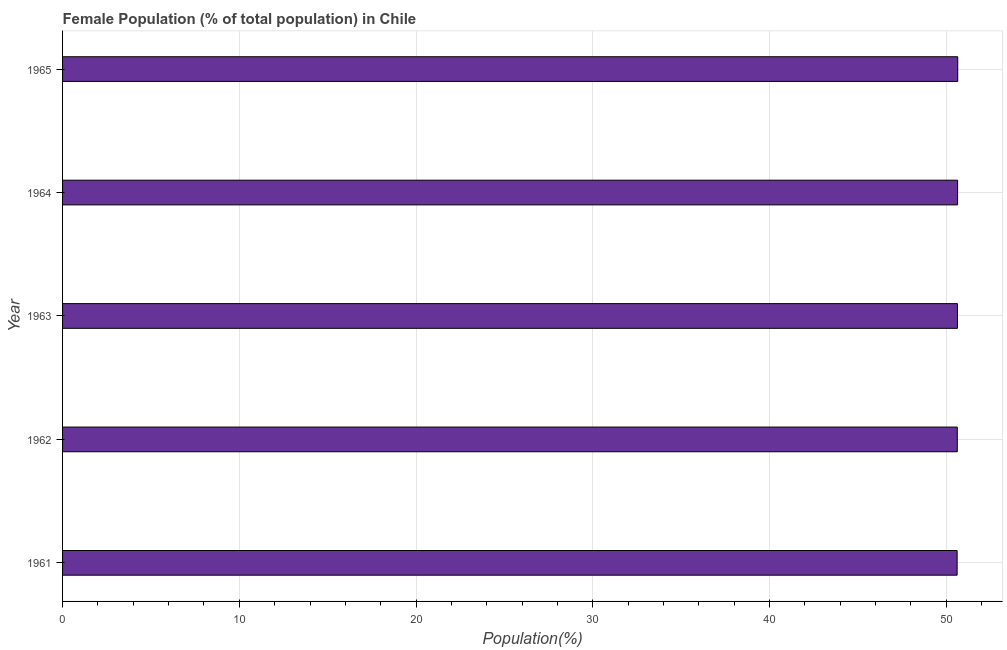Does the graph contain any zero values?
Give a very brief answer. No. Does the graph contain grids?
Make the answer very short. Yes. What is the title of the graph?
Provide a succinct answer. Female Population (% of total population) in Chile. What is the label or title of the X-axis?
Ensure brevity in your answer.  Population(%). What is the female population in 1961?
Keep it short and to the point. 50.61. Across all years, what is the maximum female population?
Your answer should be compact. 50.65. Across all years, what is the minimum female population?
Offer a terse response. 50.61. In which year was the female population maximum?
Make the answer very short. 1965. In which year was the female population minimum?
Offer a very short reply. 1961. What is the sum of the female population?
Your answer should be compact. 253.16. What is the difference between the female population in 1962 and 1964?
Your answer should be very brief. -0.02. What is the average female population per year?
Give a very brief answer. 50.63. What is the median female population?
Your answer should be very brief. 50.63. Do a majority of the years between 1961 and 1962 (inclusive) have female population greater than 12 %?
Give a very brief answer. Yes. What is the ratio of the female population in 1961 to that in 1964?
Ensure brevity in your answer.  1. Is the female population in 1962 less than that in 1965?
Provide a short and direct response. Yes. Is the difference between the female population in 1962 and 1964 greater than the difference between any two years?
Offer a terse response. No. What is the difference between the highest and the second highest female population?
Ensure brevity in your answer.  0.01. Is the sum of the female population in 1963 and 1965 greater than the maximum female population across all years?
Give a very brief answer. Yes. What is the difference between the highest and the lowest female population?
Offer a very short reply. 0.03. How many bars are there?
Provide a short and direct response. 5. What is the difference between two consecutive major ticks on the X-axis?
Your answer should be compact. 10. Are the values on the major ticks of X-axis written in scientific E-notation?
Your answer should be very brief. No. What is the Population(%) in 1961?
Offer a terse response. 50.61. What is the Population(%) in 1962?
Your response must be concise. 50.62. What is the Population(%) in 1963?
Offer a terse response. 50.63. What is the Population(%) of 1964?
Keep it short and to the point. 50.64. What is the Population(%) in 1965?
Offer a very short reply. 50.65. What is the difference between the Population(%) in 1961 and 1962?
Provide a succinct answer. -0.01. What is the difference between the Population(%) in 1961 and 1963?
Offer a very short reply. -0.02. What is the difference between the Population(%) in 1961 and 1964?
Offer a terse response. -0.03. What is the difference between the Population(%) in 1961 and 1965?
Offer a very short reply. -0.03. What is the difference between the Population(%) in 1962 and 1963?
Provide a short and direct response. -0.01. What is the difference between the Population(%) in 1962 and 1964?
Your answer should be compact. -0.02. What is the difference between the Population(%) in 1962 and 1965?
Your response must be concise. -0.03. What is the difference between the Population(%) in 1963 and 1964?
Offer a very short reply. -0.01. What is the difference between the Population(%) in 1963 and 1965?
Give a very brief answer. -0.02. What is the difference between the Population(%) in 1964 and 1965?
Offer a very short reply. -0.01. What is the ratio of the Population(%) in 1961 to that in 1963?
Your answer should be compact. 1. What is the ratio of the Population(%) in 1961 to that in 1965?
Your answer should be compact. 1. What is the ratio of the Population(%) in 1963 to that in 1965?
Make the answer very short. 1. What is the ratio of the Population(%) in 1964 to that in 1965?
Offer a terse response. 1. 